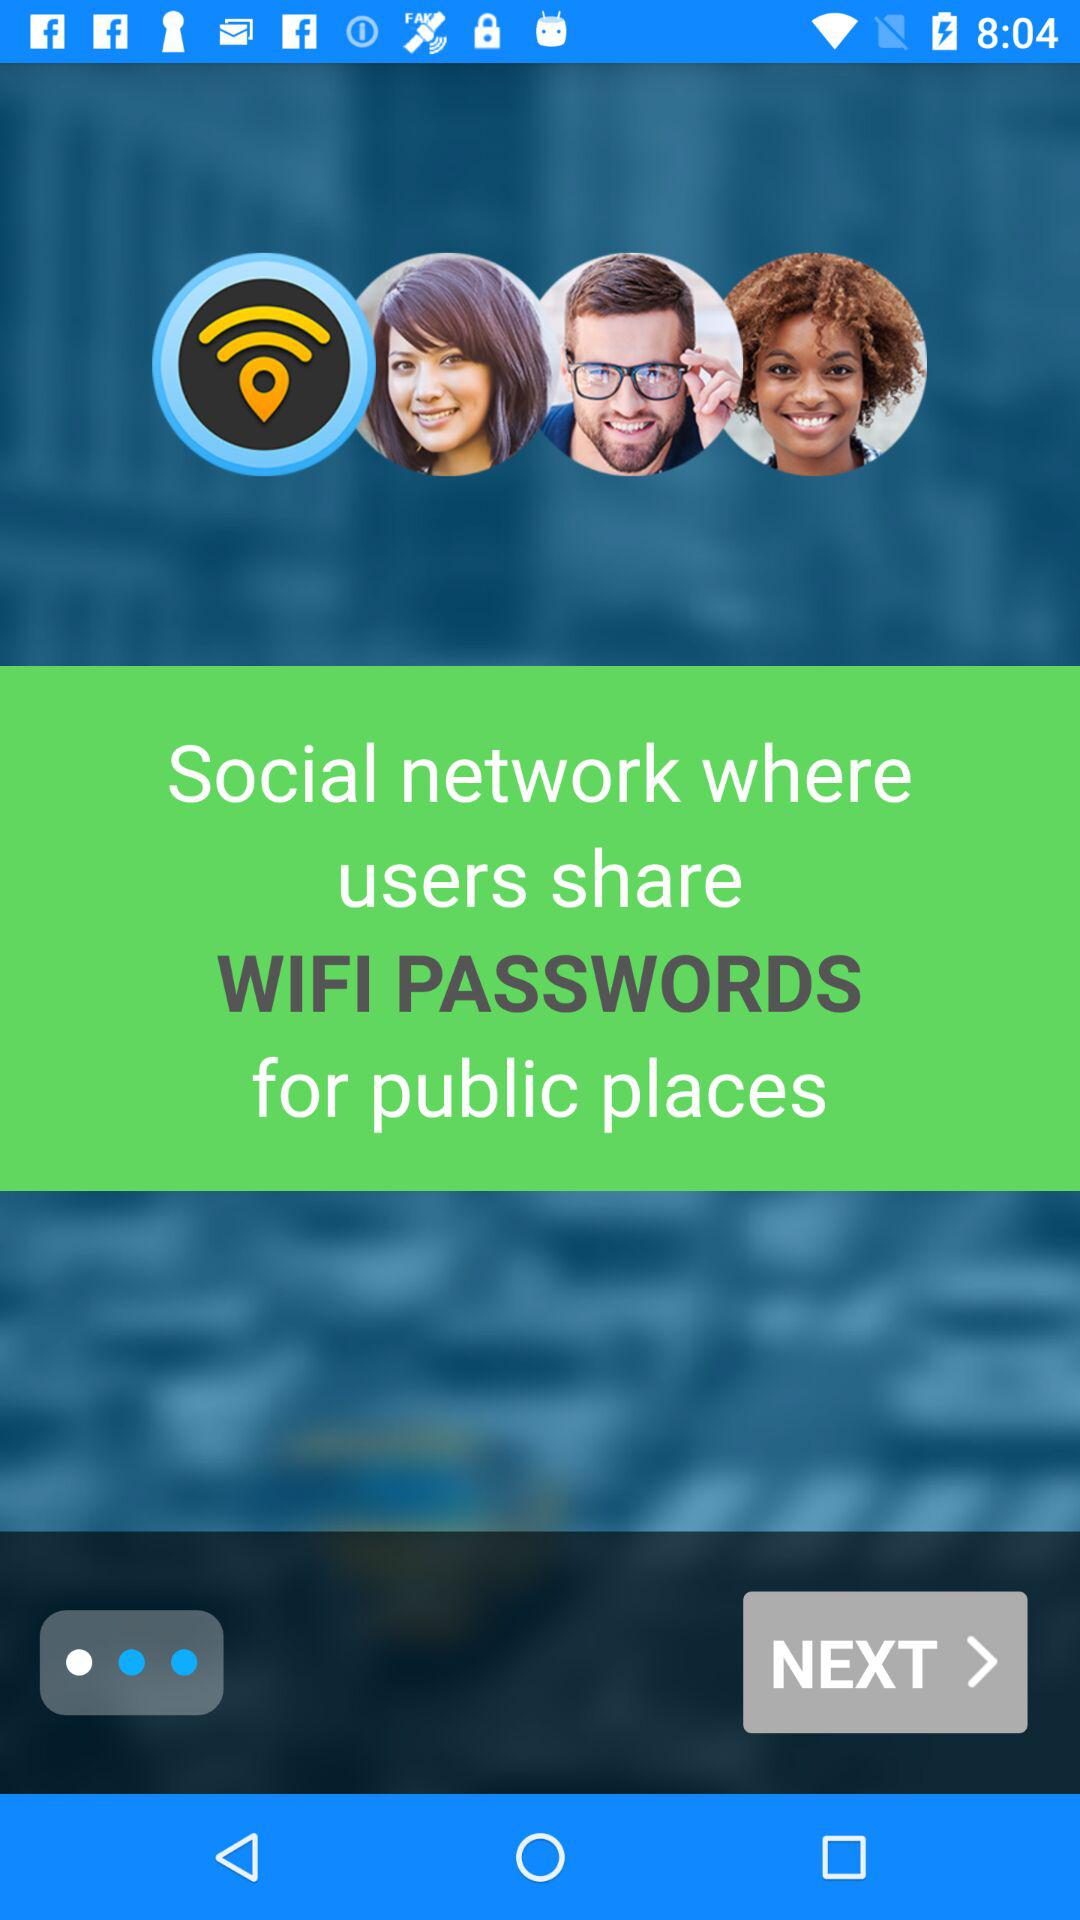How many more people are smiling in circles than there are wifi symbols?
Answer the question using a single word or phrase. 2 